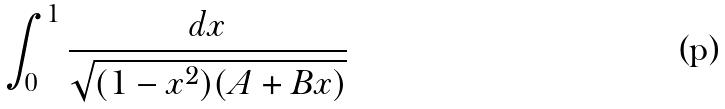<formula> <loc_0><loc_0><loc_500><loc_500>\int _ { 0 } ^ { 1 } \frac { d x } { \sqrt { ( 1 - x ^ { 2 } ) ( A + B x ) } }</formula> 